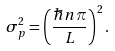<formula> <loc_0><loc_0><loc_500><loc_500>\sigma _ { p } ^ { 2 } = \left ( { \frac { \hbar { n } \pi } { L } } \right ) ^ { 2 } .</formula> 